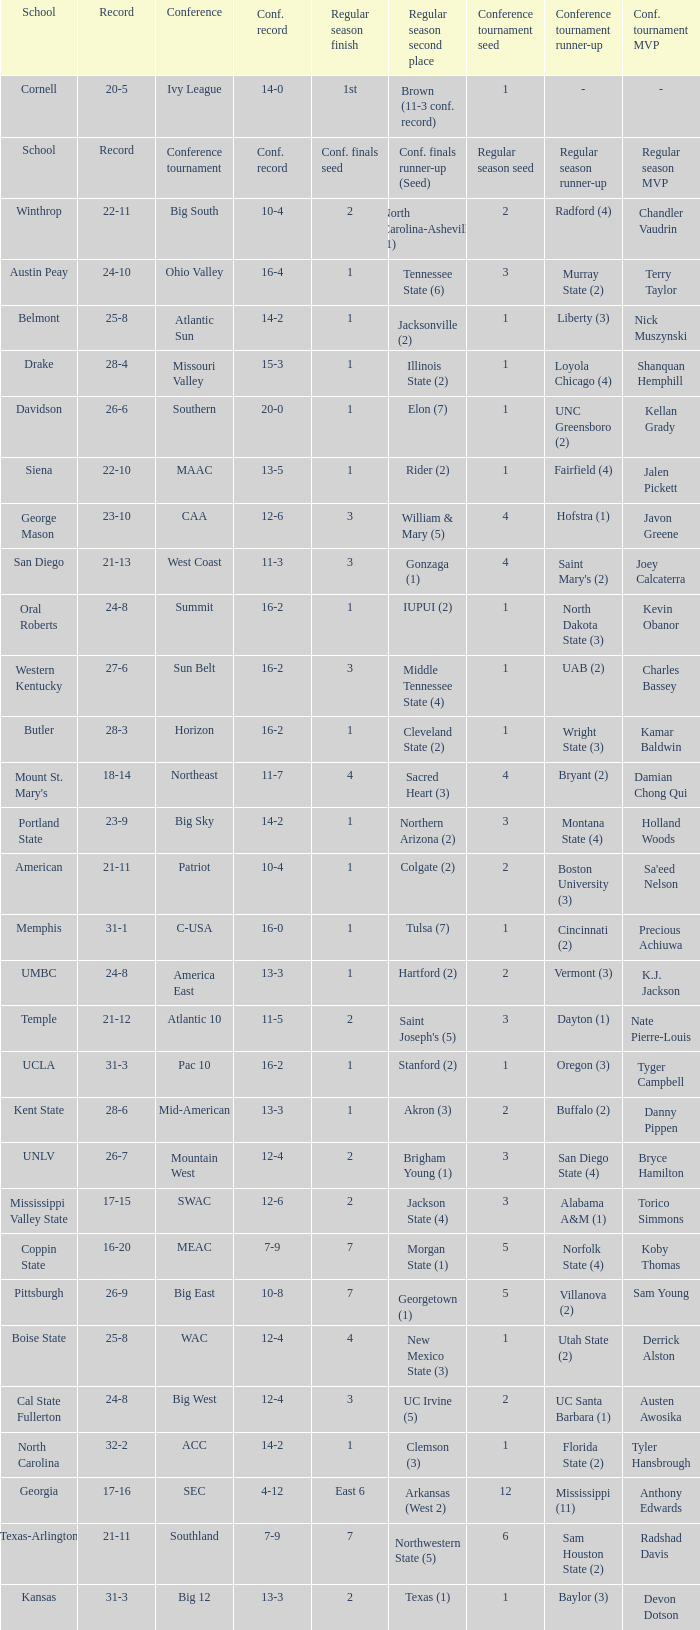Which qualifying schools were in the Patriot conference? American. 